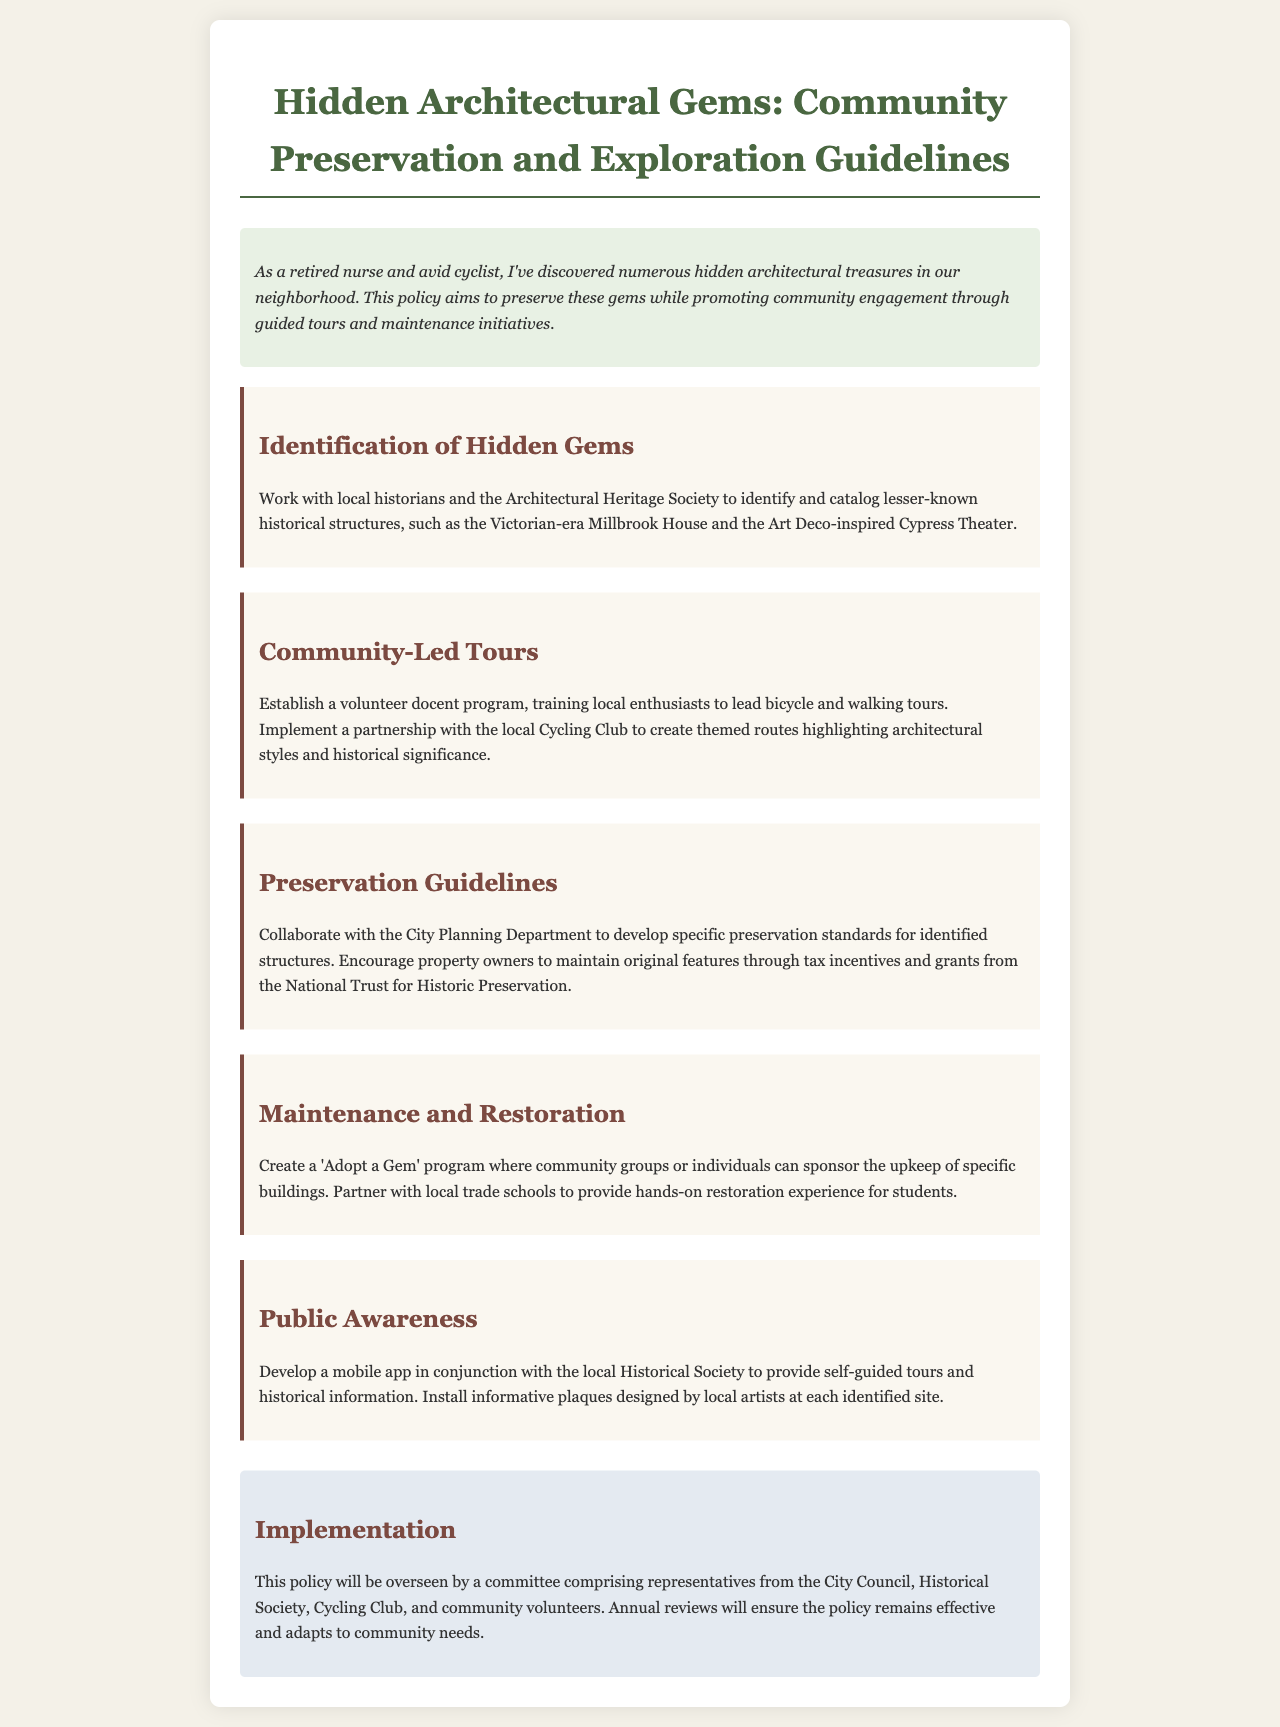What is the title of the policy document? The title of the policy document is presented at the top of the document, indicating its main focus.
Answer: Hidden Architectural Gems: Community Preservation and Exploration Guidelines What historical structure is mentioned first? The first historical structure mentioned is identified in the section discussing hidden gems, showcasing the focus on local history.
Answer: Millbrook House What program is established for community-led tours? The specific program established in the document for community-led tours involves local volunteering and engagement.
Answer: Volunteer docent program Which local institution is involved in public awareness initiatives? The local institution mentioned in conjunction with the development of a mobile app for self-guided tours is identified in the public awareness section.
Answer: Historical Society What is one method suggested for maintaining original features of buildings? The document suggests a specific incentive to encourage property owners to maintain historical structures through financial support.
Answer: Tax incentives How many groups are in the oversight committee? The oversight committee's composition is noted in the implementation section, specifying collaborations with various groups.
Answer: Four What is the name of the program for maintaining specific buildings? A specific program aimed at involving the community in building upkeep is detailed in the maintenance section, providing a catchy and engaging title.
Answer: Adopt a Gem Which architectural style is highlighted for themed routes? The themed routes created in partnership with the Cycling Club focus on highlighting particular characteristics of structures within the community.
Answer: Architectural styles What is the main goal of the policy? The overarching aim of the policy is stated in the introduction, emphasizing community engagement and preservation of local history.
Answer: Preserve hidden gems 